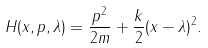Convert formula to latex. <formula><loc_0><loc_0><loc_500><loc_500>H ( x , p , \lambda ) = \frac { p ^ { 2 } } { 2 m } + \frac { k } { 2 } ( x - \lambda ) ^ { 2 } .</formula> 